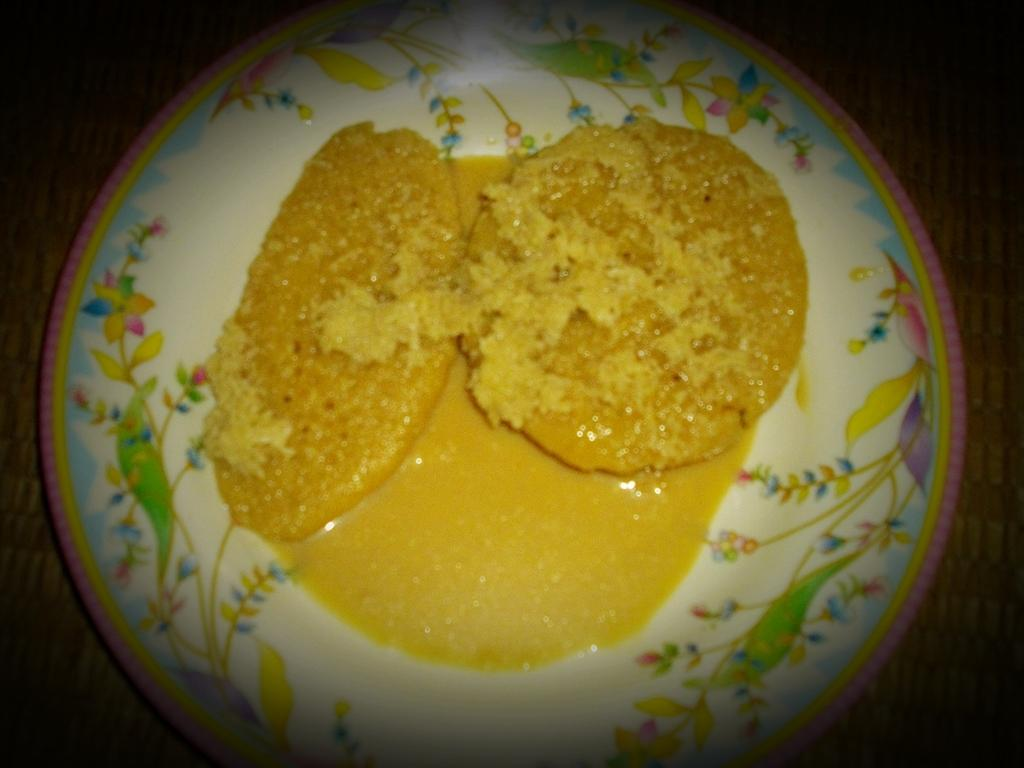What is on the plate that is visible in the image? There is a plate with food in the image. How can you describe the appearance of the plate? The plate is colorful. What is the color of the food on the plate? The food is yellow in color. On what surface is the plate placed in the image? The plate is on a brown surface. Is the girl in the image paying attention to the argument happening nearby? There is no girl or argument present in the image; it only features a plate with food on a brown surface. 